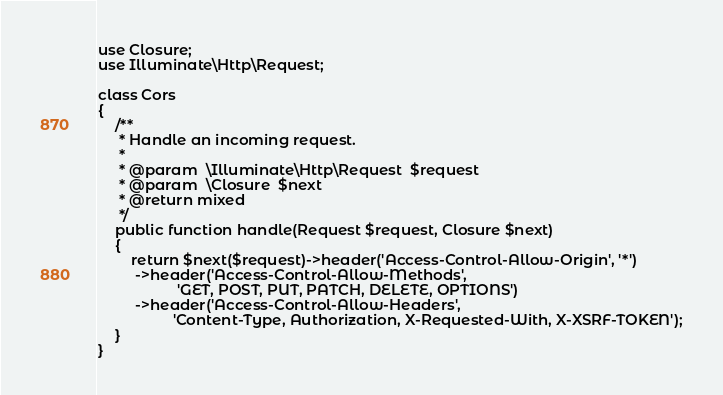Convert code to text. <code><loc_0><loc_0><loc_500><loc_500><_PHP_>use Closure;
use Illuminate\Http\Request;

class Cors
{
    /**
     * Handle an incoming request.
     *
     * @param  \Illuminate\Http\Request  $request
     * @param  \Closure  $next
     * @return mixed
     */
    public function handle(Request $request, Closure $next)
    {
        return $next($request)->header('Access-Control-Allow-Origin', '*')
         ->header('Access-Control-Allow-Methods',
                   'GET, POST, PUT, PATCH, DELETE, OPTIONS')
         ->header('Access-Control-Allow-Headers',
                  'Content-Type, Authorization, X-Requested-With, X-XSRF-TOKEN');
    }
}
</code> 